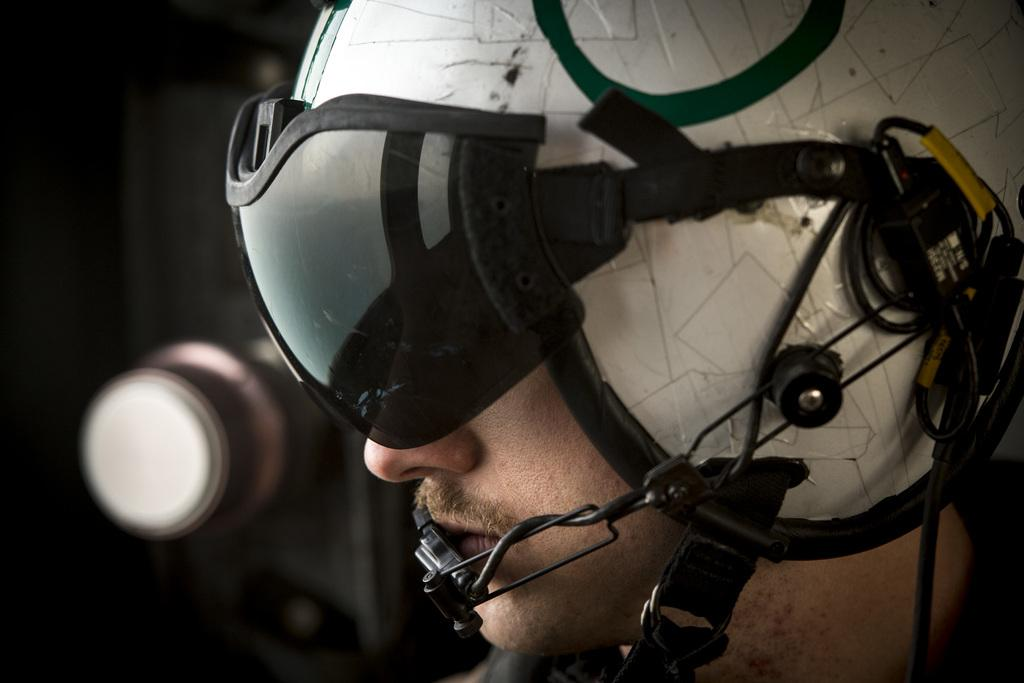Who is present in the image? There is a man in the image. What is the man wearing on his head? The man is wearing a helmet. What can be observed about the lighting in the image? The background of the image is dark. Can you describe the object visible in the background? Unfortunately, the provided facts do not give enough information to describe the object in the background. What type of tree is growing in the background of the image? There is no tree visible in the background of the image. What scientific theory is being discussed in the image? The provided facts do not mention any scientific theory being discussed in the image. 